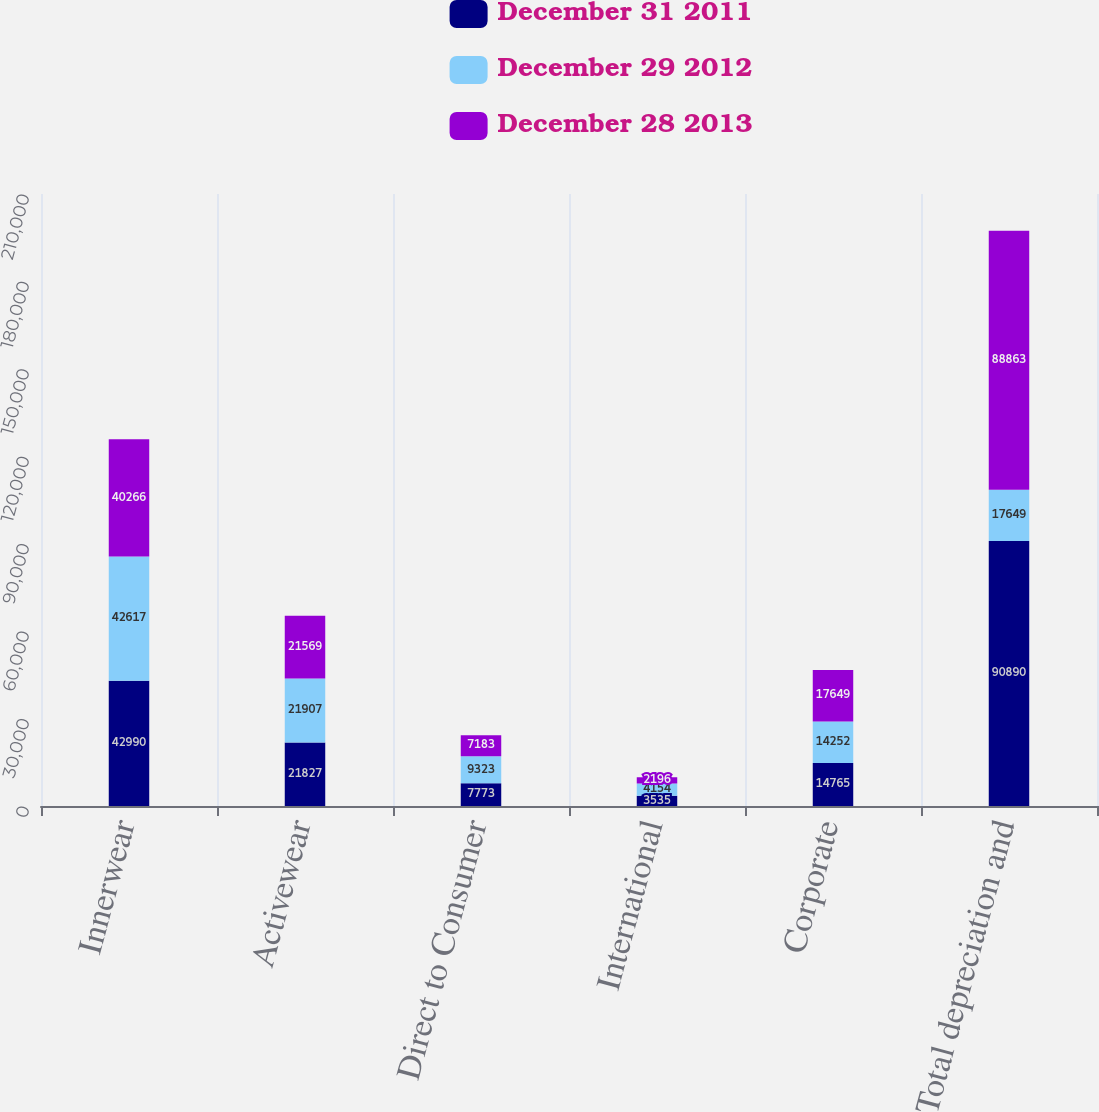Convert chart. <chart><loc_0><loc_0><loc_500><loc_500><stacked_bar_chart><ecel><fcel>Innerwear<fcel>Activewear<fcel>Direct to Consumer<fcel>International<fcel>Corporate<fcel>Total depreciation and<nl><fcel>December 31 2011<fcel>42990<fcel>21827<fcel>7773<fcel>3535<fcel>14765<fcel>90890<nl><fcel>December 29 2012<fcel>42617<fcel>21907<fcel>9323<fcel>4154<fcel>14252<fcel>17649<nl><fcel>December 28 2013<fcel>40266<fcel>21569<fcel>7183<fcel>2196<fcel>17649<fcel>88863<nl></chart> 